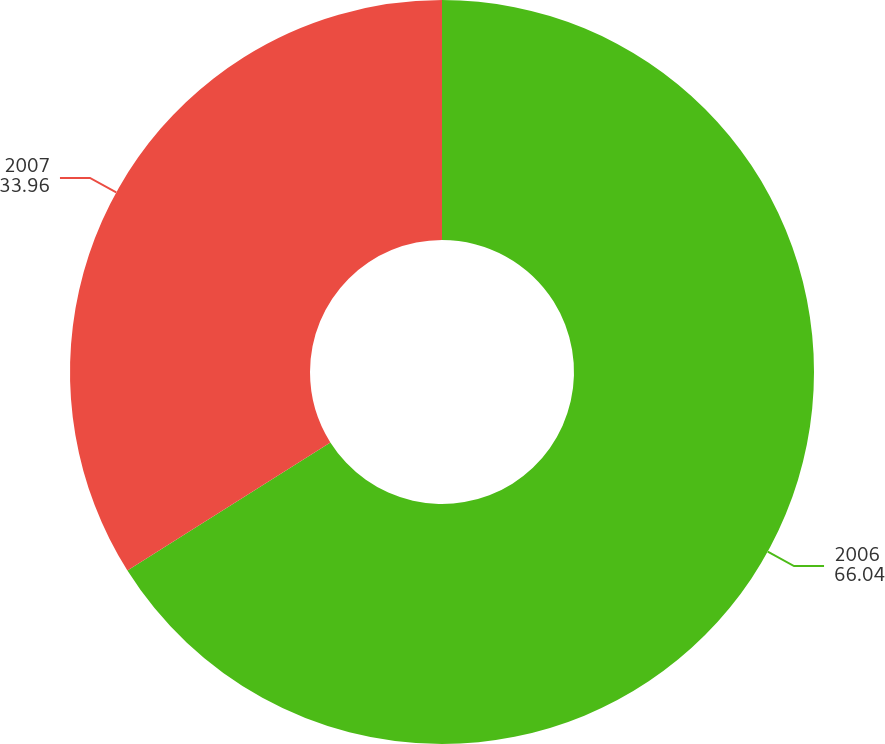<chart> <loc_0><loc_0><loc_500><loc_500><pie_chart><fcel>2006<fcel>2007<nl><fcel>66.04%<fcel>33.96%<nl></chart> 